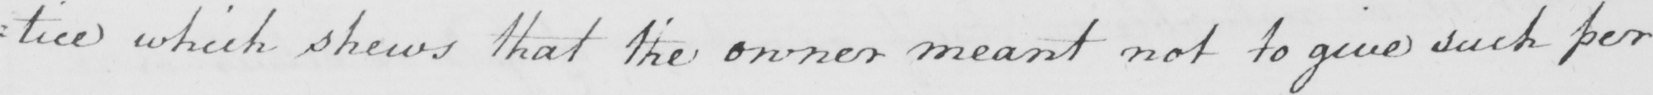Can you read and transcribe this handwriting? tice which shews that the owner meant not to give such per : 